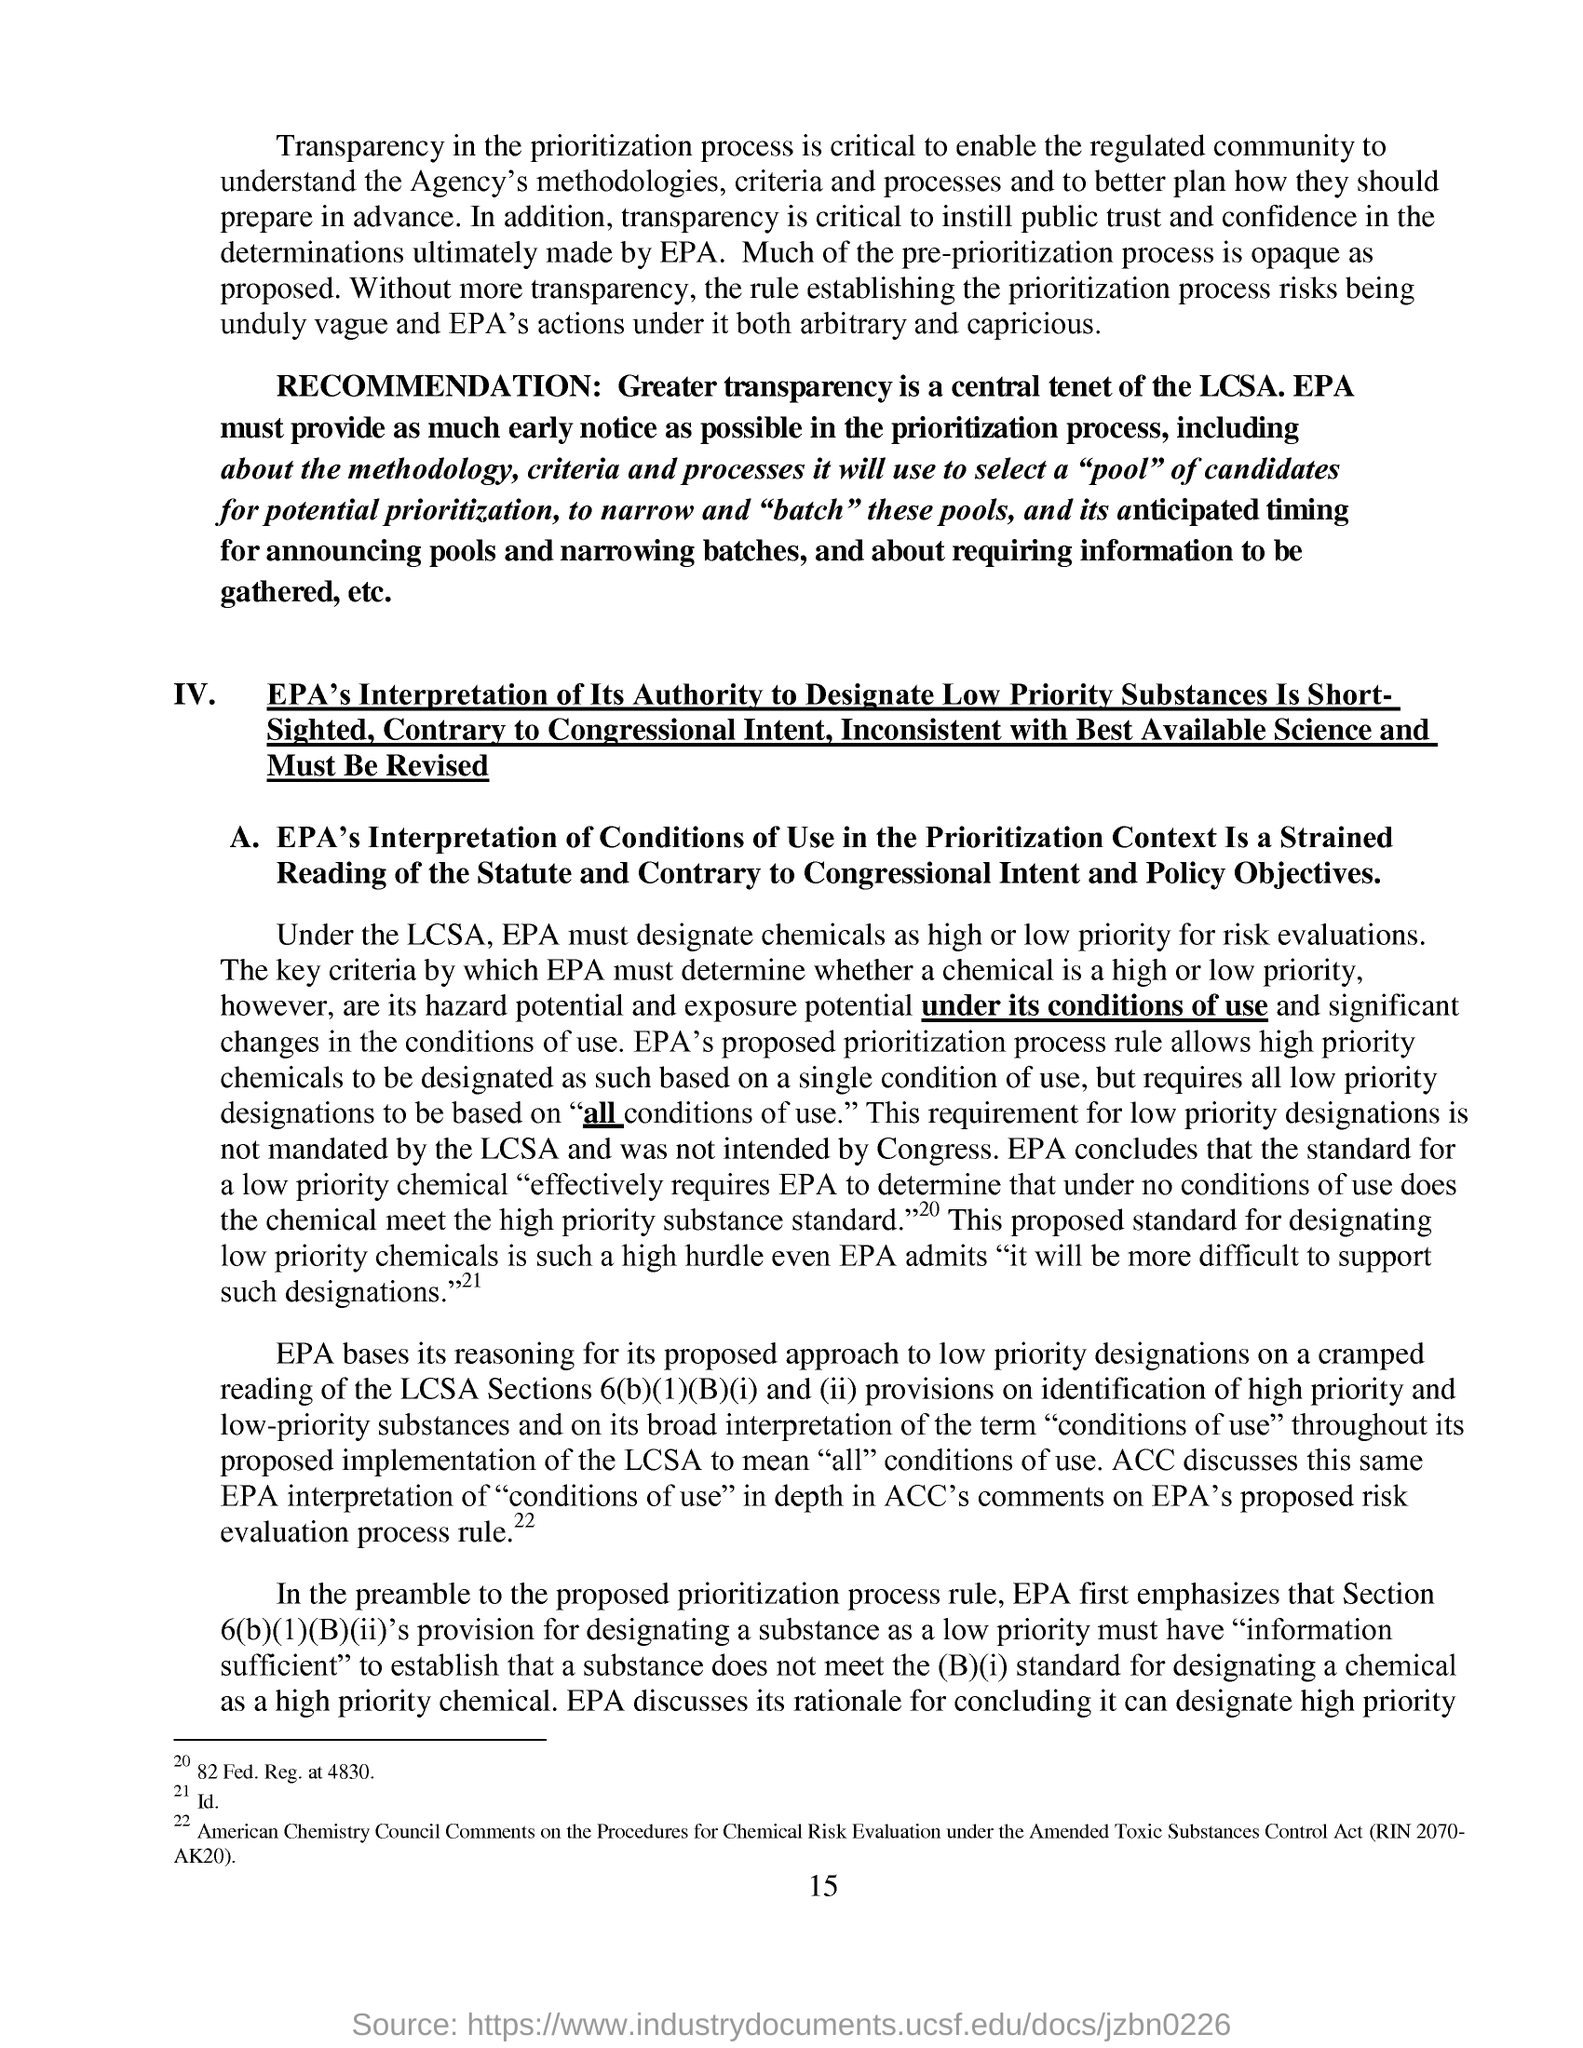Mention a couple of crucial points in this snapshot. The central tenet of LCSA as recommended by RECOMMENDATION is greater transparency. The page number indicated at the footer is 15. 